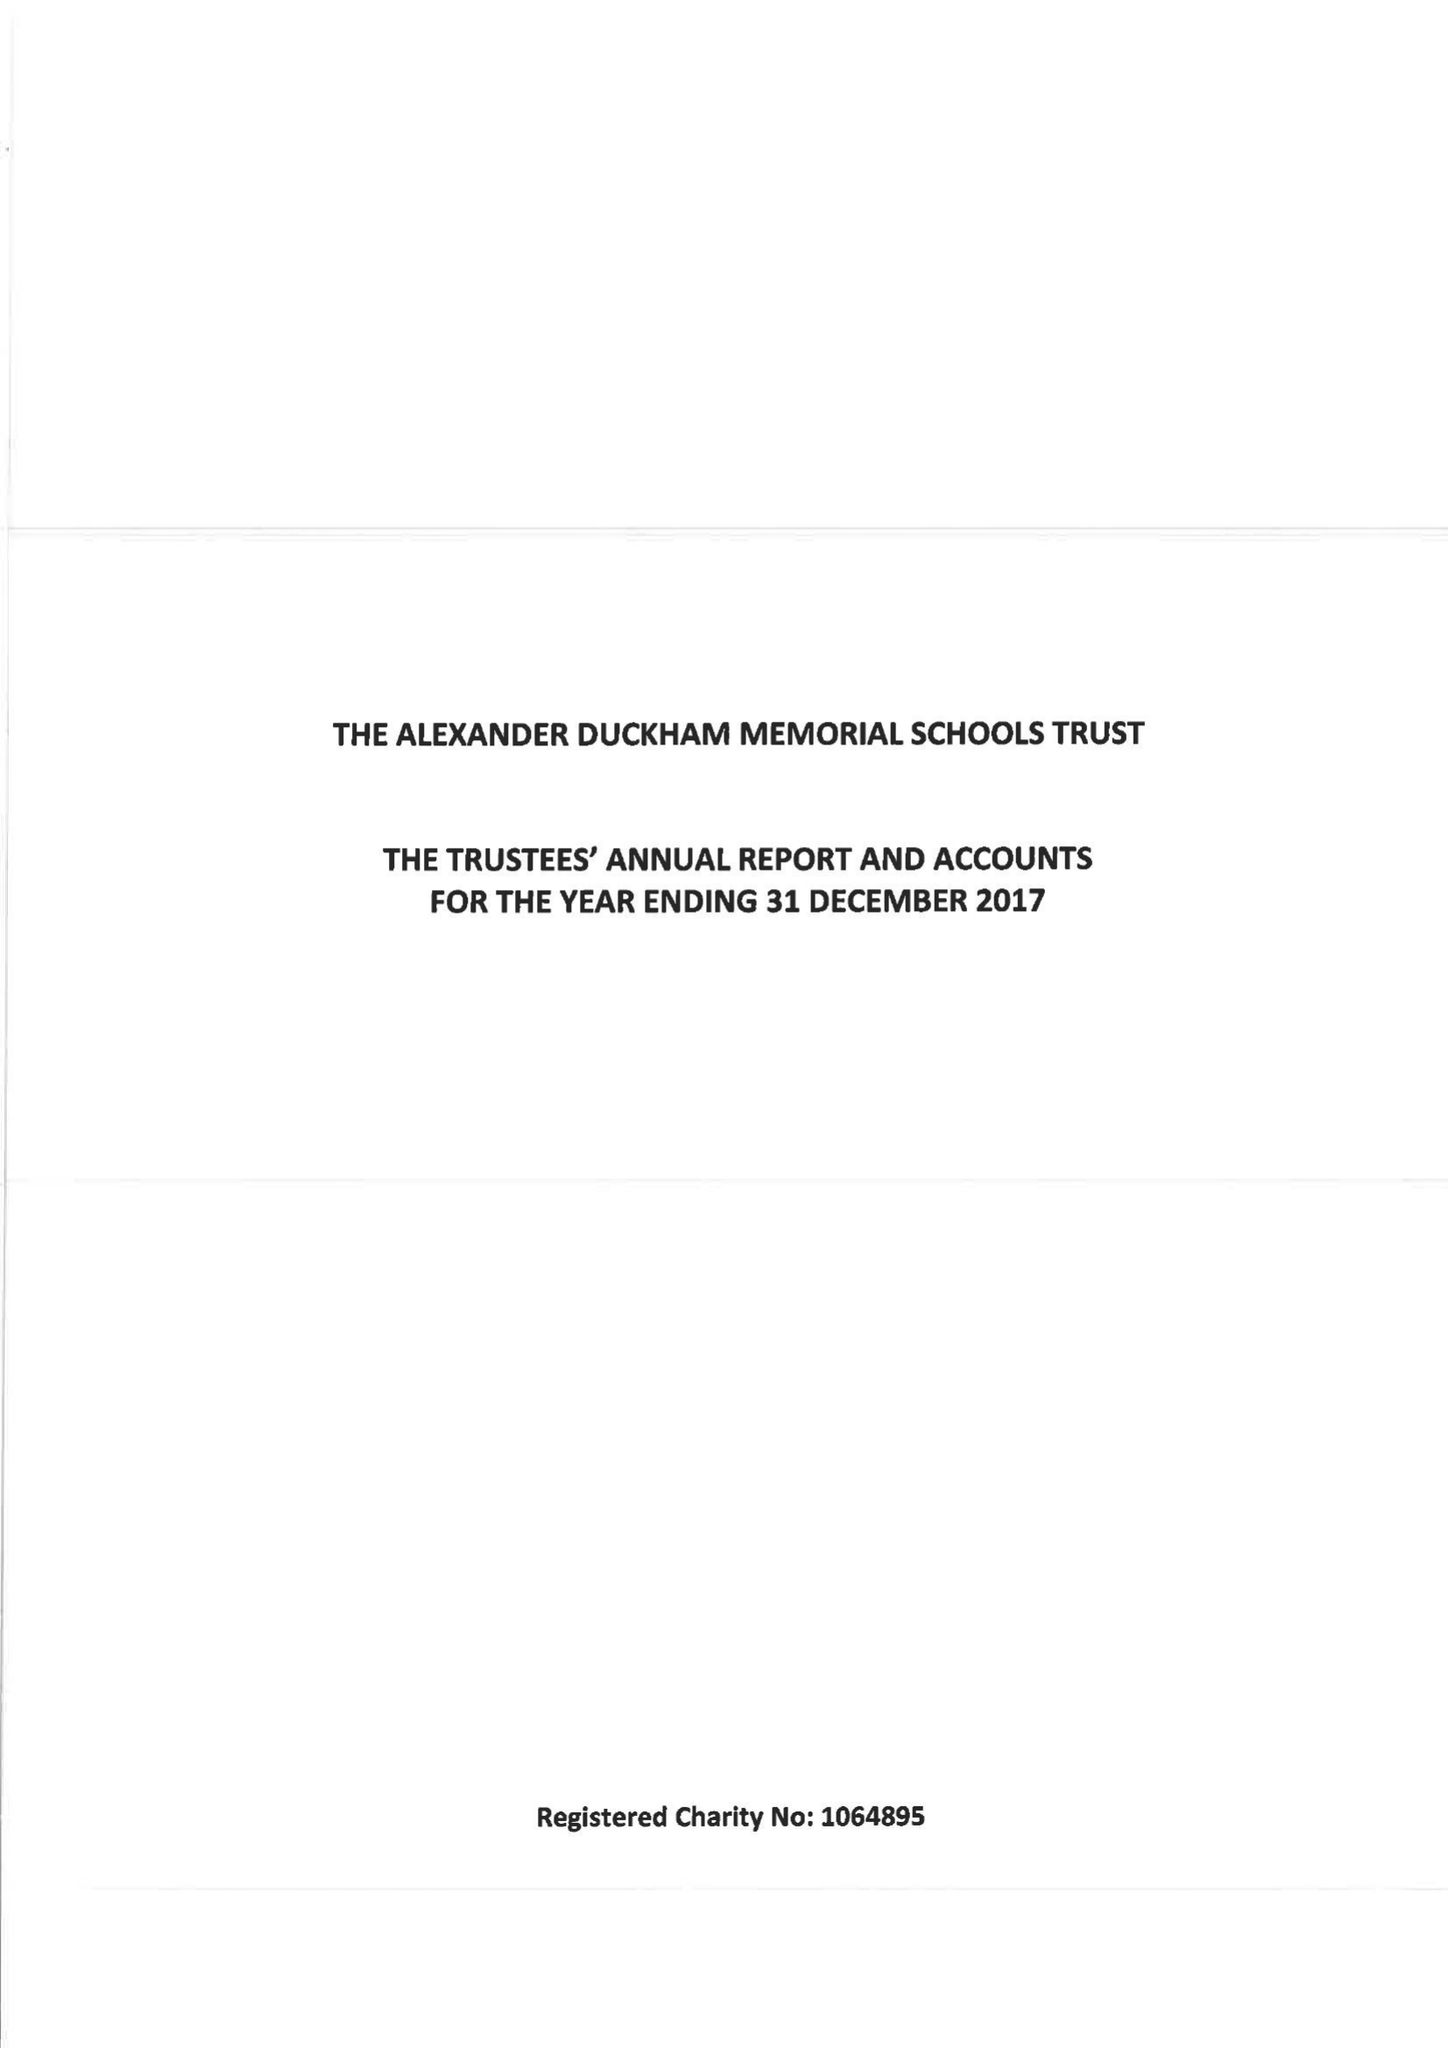What is the value for the charity_name?
Answer the question using a single word or phrase. The Alexander Duckham Memorial Schools Trust 